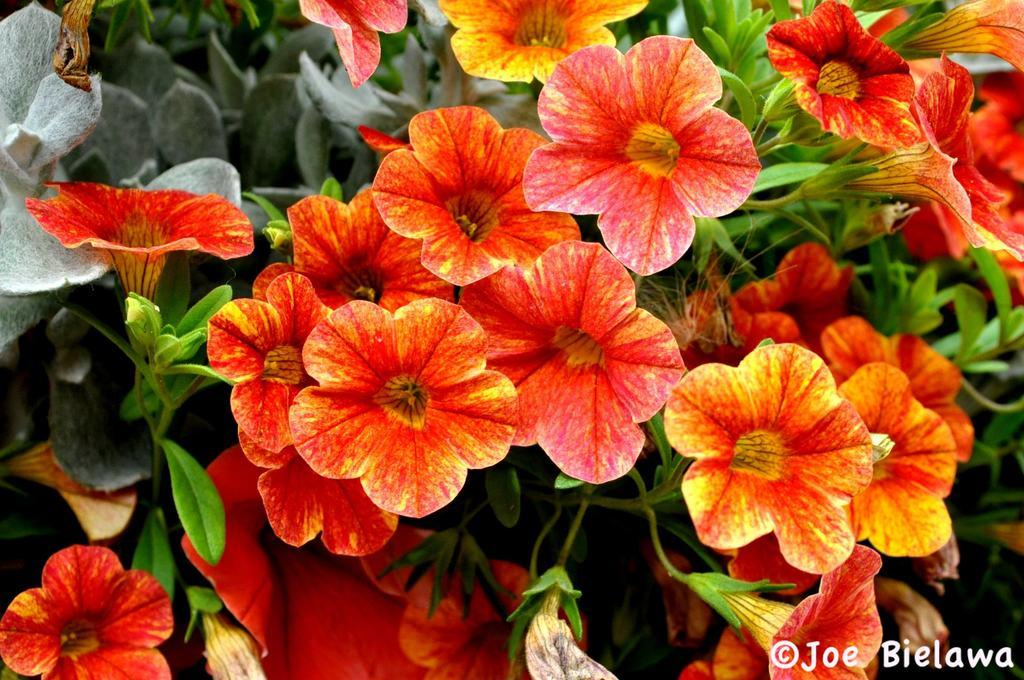What type of vegetation can be seen in the image? There are many leaves and flowers in the image. What colors are the flowers in the image? The flowers are in yellow and red colors. Is there any text present in the image? Yes, there is some text in the bottom right-hand corner of the image. What type of art can be seen on the railway in the image? There is no art or railway present in the image; it features leaves and flowers with some text. What is the position of the flowers in relation to the leaves in the image? The flowers and leaves are intermingled in the image, so it is not possible to determine a specific position relative to each other. 